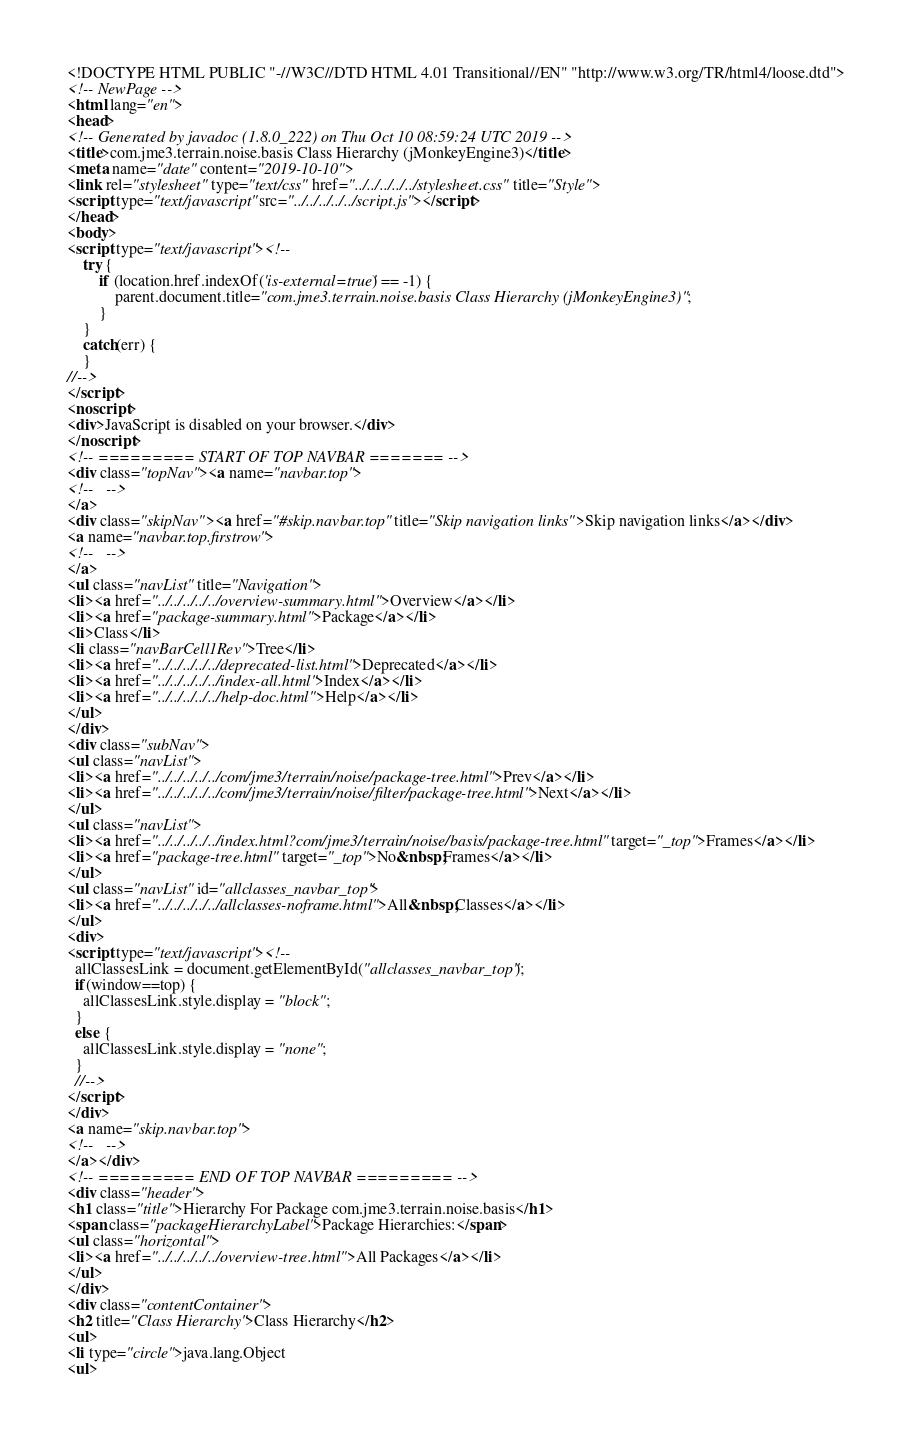<code> <loc_0><loc_0><loc_500><loc_500><_HTML_><!DOCTYPE HTML PUBLIC "-//W3C//DTD HTML 4.01 Transitional//EN" "http://www.w3.org/TR/html4/loose.dtd">
<!-- NewPage -->
<html lang="en">
<head>
<!-- Generated by javadoc (1.8.0_222) on Thu Oct 10 08:59:24 UTC 2019 -->
<title>com.jme3.terrain.noise.basis Class Hierarchy (jMonkeyEngine3)</title>
<meta name="date" content="2019-10-10">
<link rel="stylesheet" type="text/css" href="../../../../../stylesheet.css" title="Style">
<script type="text/javascript" src="../../../../../script.js"></script>
</head>
<body>
<script type="text/javascript"><!--
    try {
        if (location.href.indexOf('is-external=true') == -1) {
            parent.document.title="com.jme3.terrain.noise.basis Class Hierarchy (jMonkeyEngine3)";
        }
    }
    catch(err) {
    }
//-->
</script>
<noscript>
<div>JavaScript is disabled on your browser.</div>
</noscript>
<!-- ========= START OF TOP NAVBAR ======= -->
<div class="topNav"><a name="navbar.top">
<!--   -->
</a>
<div class="skipNav"><a href="#skip.navbar.top" title="Skip navigation links">Skip navigation links</a></div>
<a name="navbar.top.firstrow">
<!--   -->
</a>
<ul class="navList" title="Navigation">
<li><a href="../../../../../overview-summary.html">Overview</a></li>
<li><a href="package-summary.html">Package</a></li>
<li>Class</li>
<li class="navBarCell1Rev">Tree</li>
<li><a href="../../../../../deprecated-list.html">Deprecated</a></li>
<li><a href="../../../../../index-all.html">Index</a></li>
<li><a href="../../../../../help-doc.html">Help</a></li>
</ul>
</div>
<div class="subNav">
<ul class="navList">
<li><a href="../../../../../com/jme3/terrain/noise/package-tree.html">Prev</a></li>
<li><a href="../../../../../com/jme3/terrain/noise/filter/package-tree.html">Next</a></li>
</ul>
<ul class="navList">
<li><a href="../../../../../index.html?com/jme3/terrain/noise/basis/package-tree.html" target="_top">Frames</a></li>
<li><a href="package-tree.html" target="_top">No&nbsp;Frames</a></li>
</ul>
<ul class="navList" id="allclasses_navbar_top">
<li><a href="../../../../../allclasses-noframe.html">All&nbsp;Classes</a></li>
</ul>
<div>
<script type="text/javascript"><!--
  allClassesLink = document.getElementById("allclasses_navbar_top");
  if(window==top) {
    allClassesLink.style.display = "block";
  }
  else {
    allClassesLink.style.display = "none";
  }
  //-->
</script>
</div>
<a name="skip.navbar.top">
<!--   -->
</a></div>
<!-- ========= END OF TOP NAVBAR ========= -->
<div class="header">
<h1 class="title">Hierarchy For Package com.jme3.terrain.noise.basis</h1>
<span class="packageHierarchyLabel">Package Hierarchies:</span>
<ul class="horizontal">
<li><a href="../../../../../overview-tree.html">All Packages</a></li>
</ul>
</div>
<div class="contentContainer">
<h2 title="Class Hierarchy">Class Hierarchy</h2>
<ul>
<li type="circle">java.lang.Object
<ul></code> 